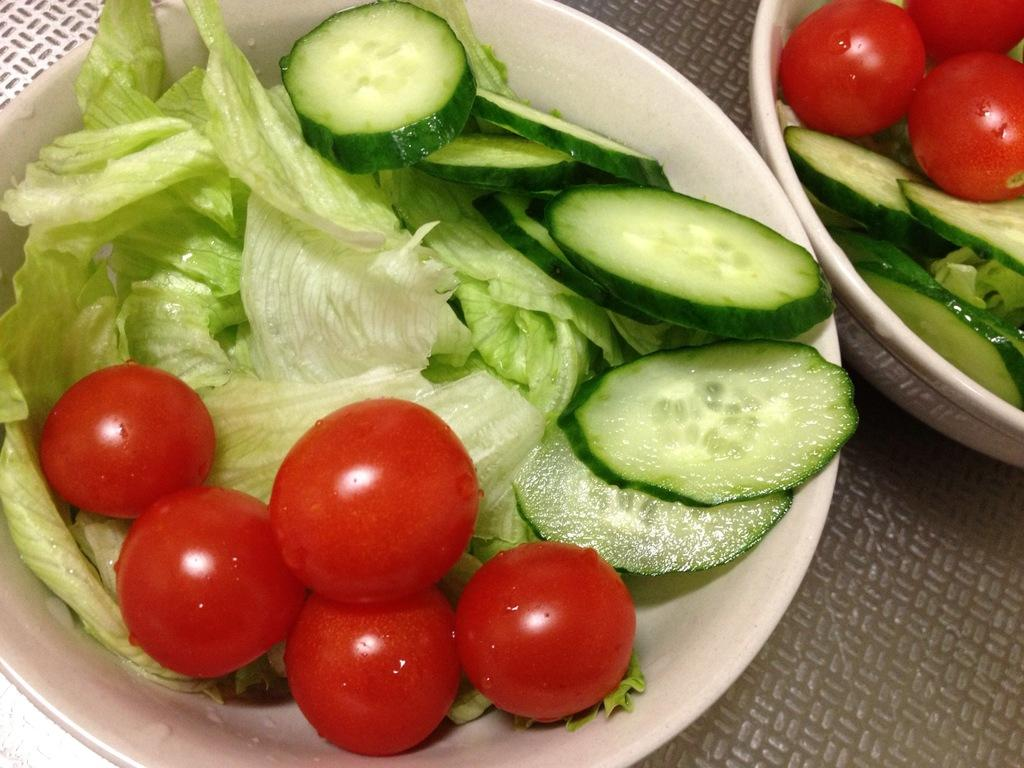What type of food can be seen in the image? There are vegetables in the image. How are the vegetables arranged or presented in the image? The vegetables are in bowls. Can you tell me the income of the snake in the image? There is no snake present in the image, so it is not possible to determine its income. 